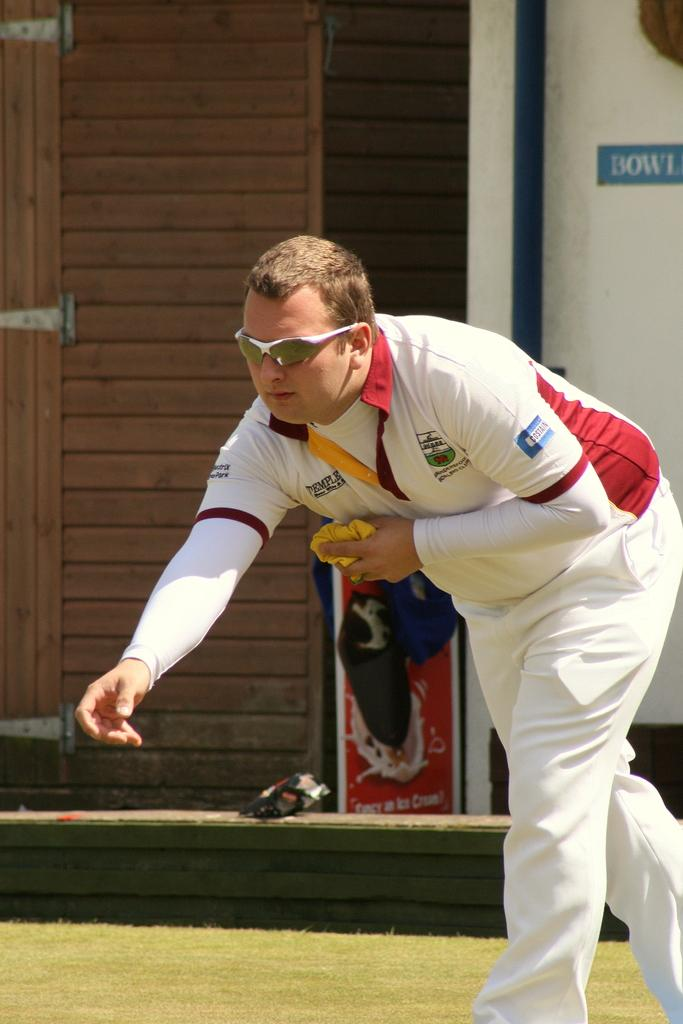What is the man in the image doing? The man is standing on the ground and holding a cloth in the image. What type of surface is visible under the man's feet? There is grass visible in the image. What type of structure can be seen in the image? There is a wooden door in the image. What is attached to the wall in the image? There is a board on a wall in the image. What type of railway can be seen in the image? There is no railway present in the image. How does the man plan to expand the wooden door in the image? The image does not show any indication of the man planning to expand the wooden door, nor does it show any tools or materials for expansion. 